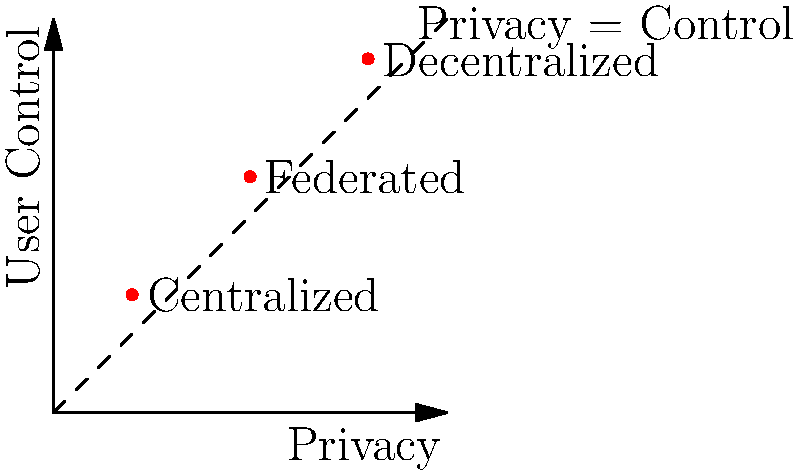In the diagram comparing privacy implications of different data storage architectures, which architecture provides the highest level of both privacy and user control? How does this relate to the ethical responsibilities of software engineers in designing systems? To answer this question, we need to analyze the diagram and understand the implications for software engineering ethics:

1. The diagram plots three data storage architectures: Centralized, Federated, and Decentralized.
2. The x-axis represents Privacy, and the y-axis represents User Control.
3. Each architecture is represented by a point on the graph.
4. Analyzing the points:
   - Centralized: Lowest on both privacy and user control
   - Federated: Middle position on both axes
   - Decentralized: Highest on both privacy and user control
5. The decentralized architecture is closest to the top-right corner, indicating the highest levels of both privacy and user control.
6. For software engineers concerned with the societal impact of code:
   - This implies that decentralized architectures are most aligned with ethical considerations of user privacy and control.
   - Choosing decentralized architectures when possible can be seen as taking responsibility for the impact of one's code.
   - It demonstrates a commitment to prioritizing user rights and data protection in system design.

Therefore, the decentralized architecture provides the highest level of both privacy and user control, aligning with the ethical responsibility of software engineers to consider and mitigate the societal impact of their code through thoughtful system design.
Answer: Decentralized architecture; aligns with ethical responsibility to prioritize user privacy and control in system design. 